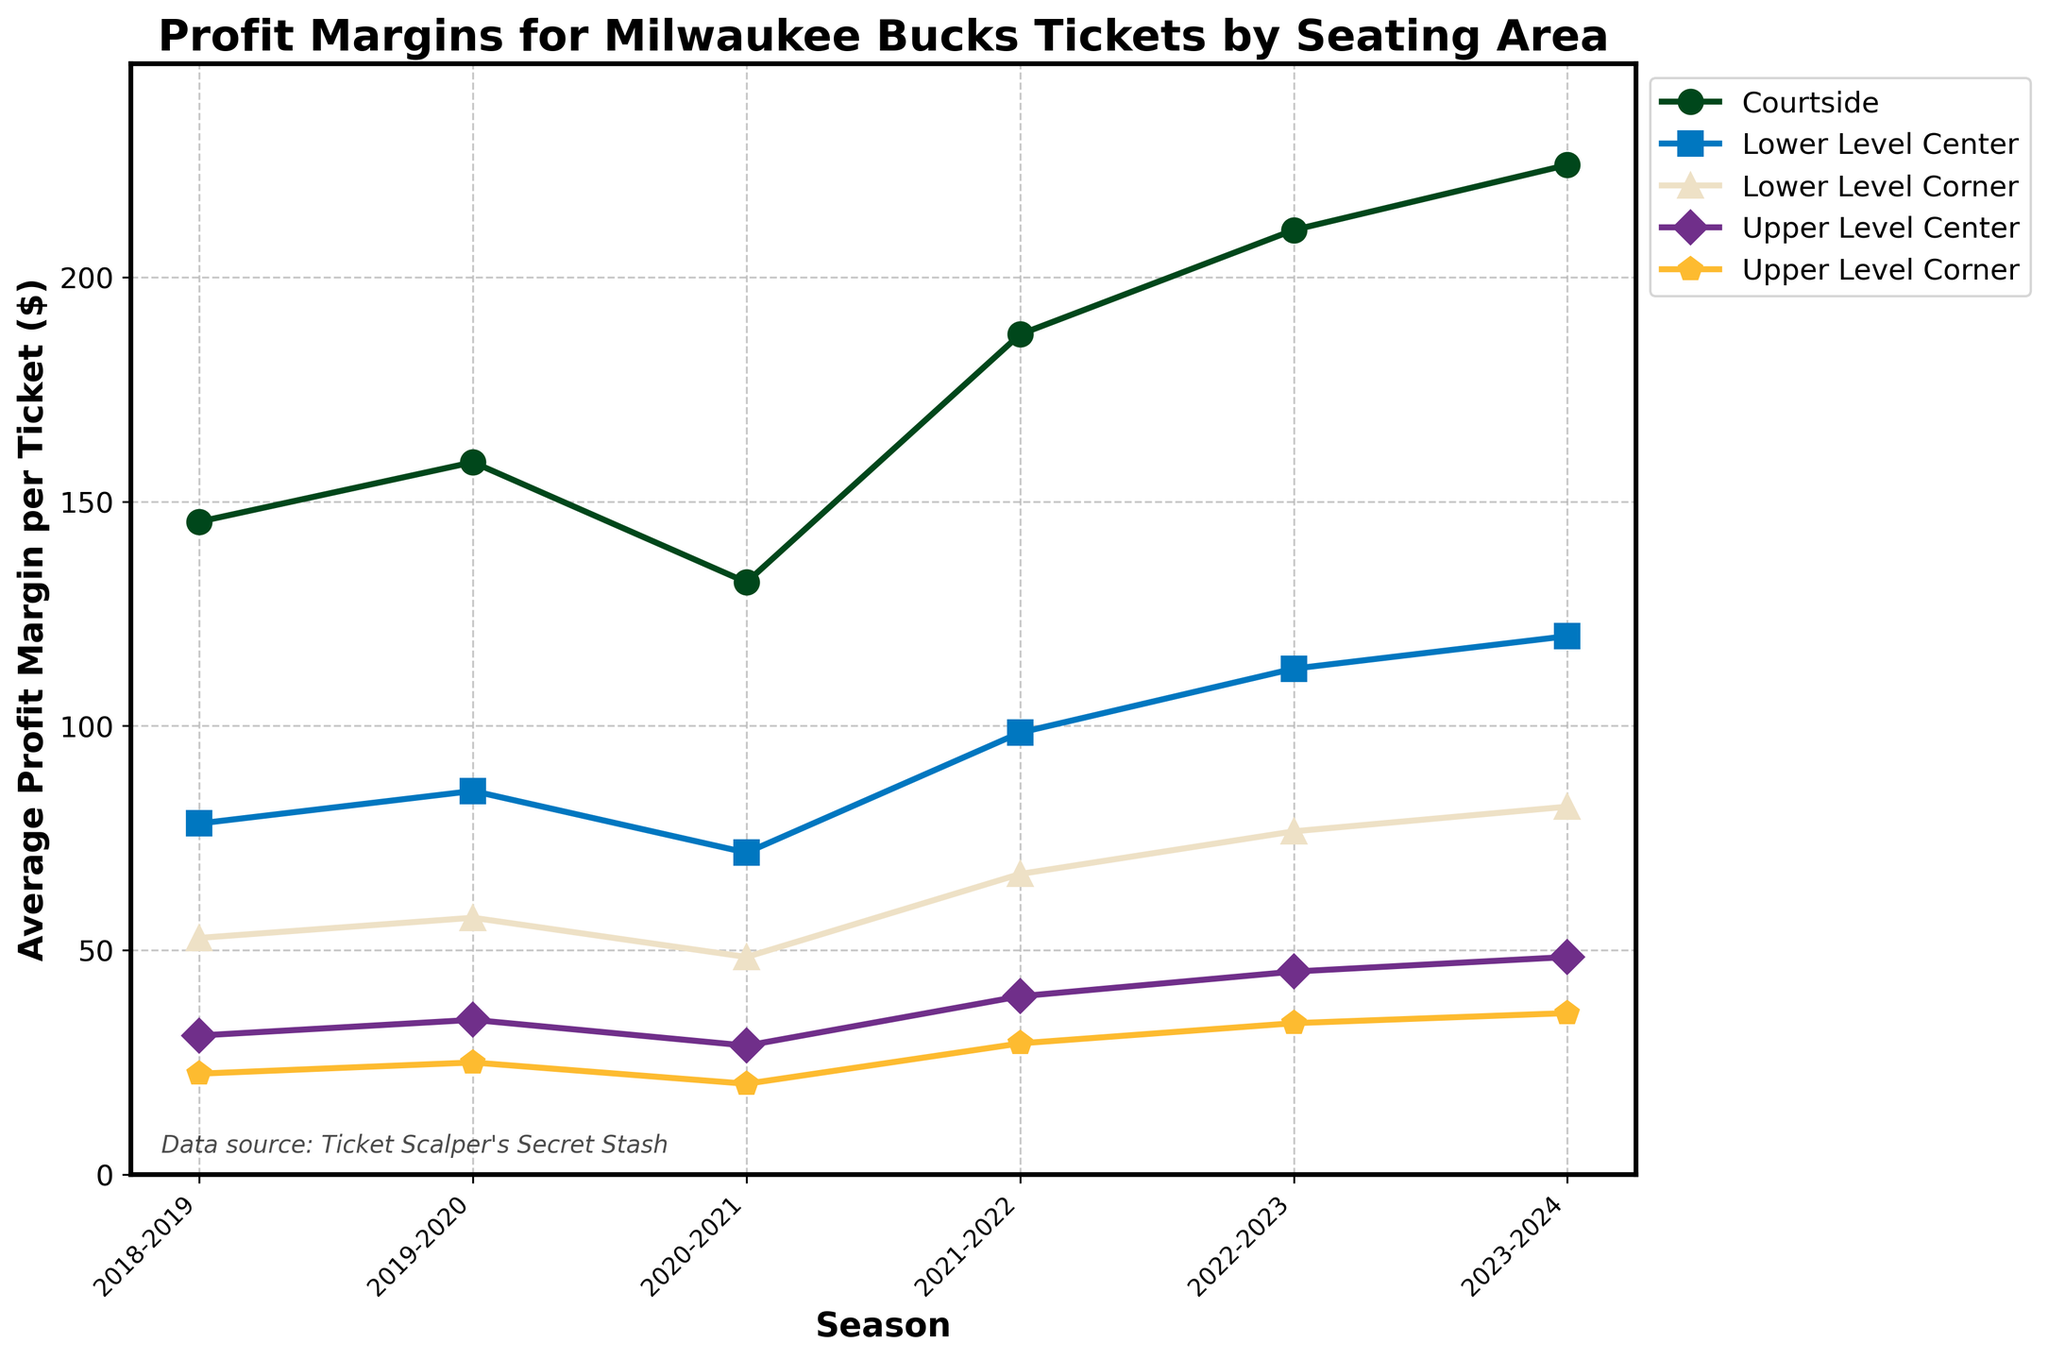What trend do you see in the profit margins for Courtside seats from the 2018-2019 season to the 2023-2024 season? The profit margins for Courtside seats show a generally increasing trend from the 2018-2019 season ($145.50) to the 2023-2024 season ($225.00), with a slight dip in the 2020-2021 season where it dropped to $132.00.
Answer: Increasing with a dip in 2020-2021 Which seating area had the highest profit margin in the 2021-2022 season, and what was the value? Looking at the figure for the 2021-2022 season, Courtside seats had the highest profit margin at $187.25.
Answer: Courtside, $187.25 Compare the profit margins for Lower Level Center seats between the 2019-2020 season and the 2023-2024 season. Which season had a higher profit margin and by how much? In the 2019-2020 season, the profit margin for Lower Level Center seats was $85.50, and in the 2023-2024 season, it was $120.00. The 2023-2024 season had a higher profit margin by $120.00 - $85.50 = $34.50.
Answer: 2023-2024 by $34.50 Which season shows the lowest profit margin for Upper Level Corner seats, and what is the value? Checking each season's value for Upper Level Corner seats, the 2020-2021 season has the lowest profit margin at $20.25.
Answer: 2020-2021, $20.25 By how much did the average profit margin for Lower Level Corner seats change from the 2018-2019 season to the 2022-2023 season? In the 2018-2019 season, the profit margin for Lower Level Corner seats was $52.75. In the 2022-2023 season, it was $76.50. The change is $76.50 - $52.75 = $23.75.
Answer: $23.75 increase What is the percentage change in profit margin for Upper Level Center seats from the 2018-2019 season to the 2023-2024 season? The profit margin for Upper Level Center seats was $31.00 in the 2018-2019 season and $48.50 in the 2023-2024 season. The percentage change is calculated as ((48.50 - 31.00) / 31.00) * 100 = 56.45%.
Answer: 56.45% In which seasons did the Upper Level Center and Upper Level Corner seats show an increasing trend in profit margins? Both Upper Level Center and Upper Level Corner seats show a consistent increase in profit margins from the 2020-2021 season to the 2023-2024 season.
Answer: 2020-2021 to 2023-2024 Is there any season where the profit margin for Courtside seats decreased compared to the previous season? If so, which season and by how much? The 2020-2021 season shows a decrease in profit margin for Courtside seats compared to the 2019-2020 season. The decrease is $158.75 (2019-2020) - $132.00 (2020-2021) = $26.75.
Answer: 2020-2021, $26.75 decrease 